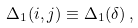<formula> <loc_0><loc_0><loc_500><loc_500>\Delta _ { 1 } ( { i , j } ) \equiv \Delta _ { 1 } ( { \delta } ) \, ,</formula> 